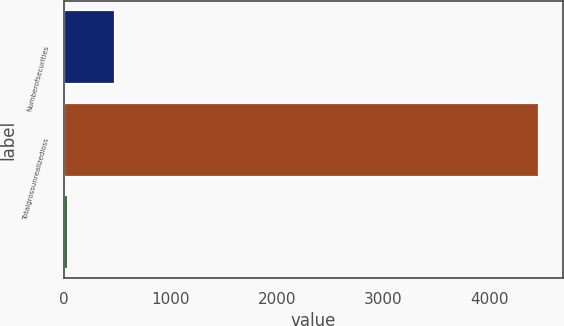Convert chart. <chart><loc_0><loc_0><loc_500><loc_500><bar_chart><fcel>Numberofsecurities<fcel>Totalgrossunrealizedloss<fcel>Unnamed: 2<nl><fcel>485.2<fcel>4465<fcel>43<nl></chart> 